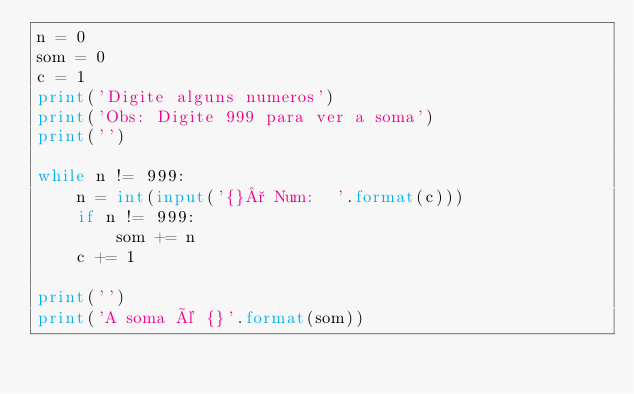Convert code to text. <code><loc_0><loc_0><loc_500><loc_500><_Python_>n = 0
som = 0
c = 1
print('Digite alguns numeros')
print('Obs: Digite 999 para ver a soma')
print('')

while n != 999:
    n = int(input('{}° Num:  '.format(c)))
    if n != 999:
        som += n
    c += 1

print('')
print('A soma é {}'.format(som))
</code> 